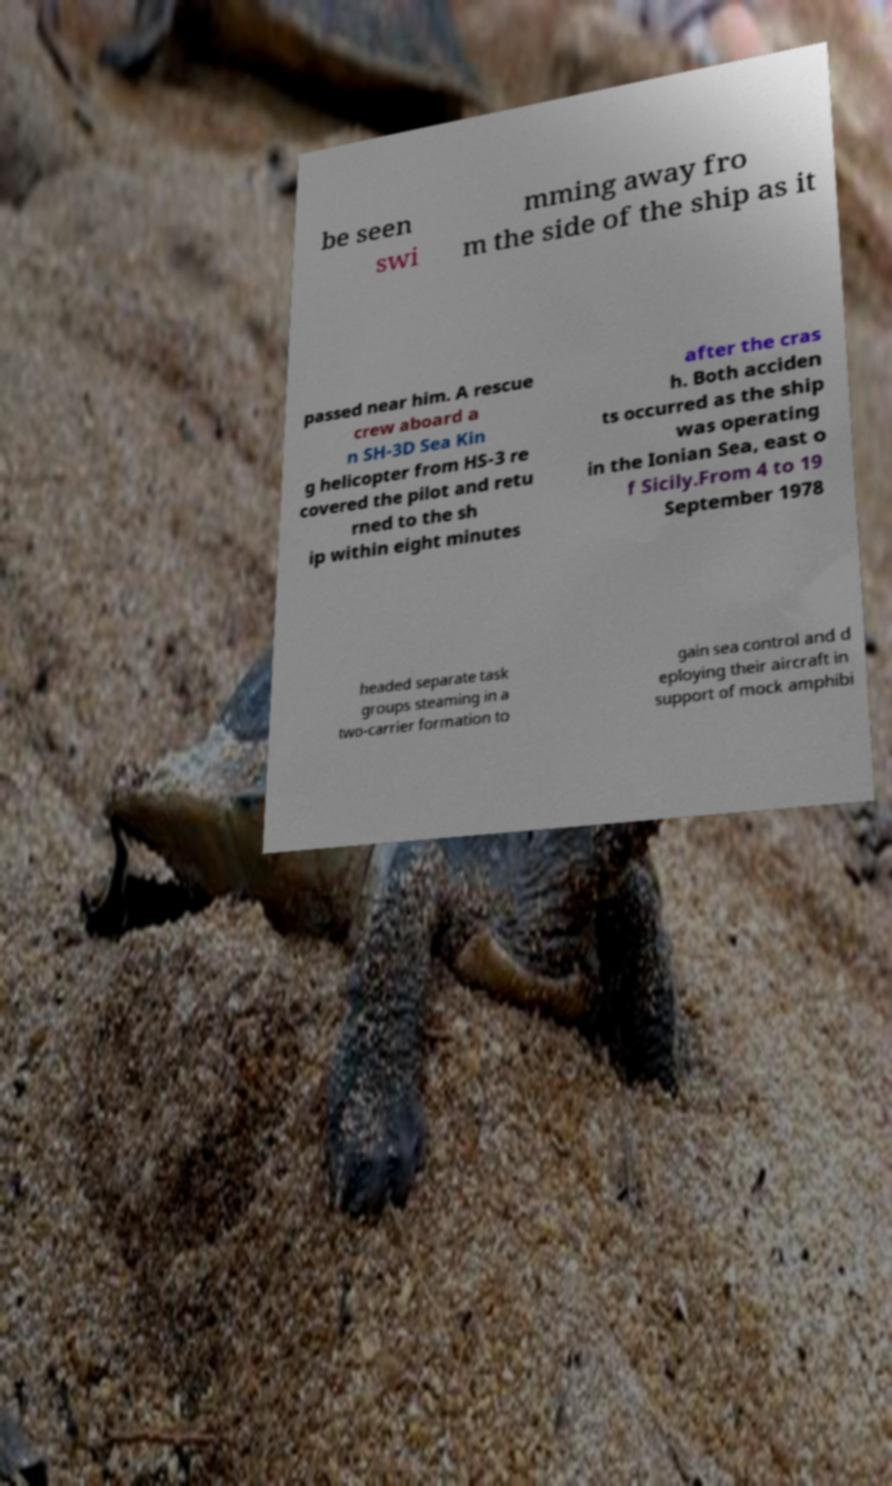For documentation purposes, I need the text within this image transcribed. Could you provide that? be seen swi mming away fro m the side of the ship as it passed near him. A rescue crew aboard a n SH-3D Sea Kin g helicopter from HS-3 re covered the pilot and retu rned to the sh ip within eight minutes after the cras h. Both acciden ts occurred as the ship was operating in the Ionian Sea, east o f Sicily.From 4 to 19 September 1978 headed separate task groups steaming in a two-carrier formation to gain sea control and d eploying their aircraft in support of mock amphibi 